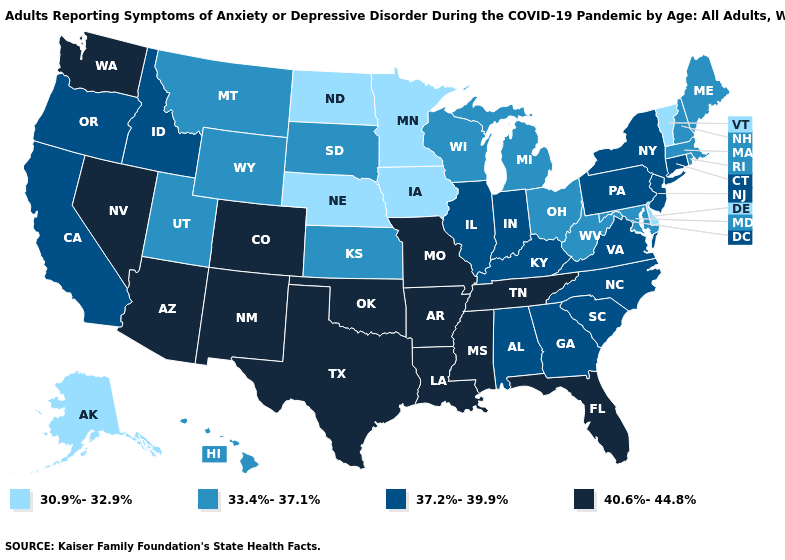Among the states that border Kansas , does Colorado have the lowest value?
Be succinct. No. Does Delaware have a higher value than Nevada?
Short answer required. No. Does Arkansas have the same value as New Mexico?
Keep it brief. Yes. Is the legend a continuous bar?
Concise answer only. No. Name the states that have a value in the range 37.2%-39.9%?
Be succinct. Alabama, California, Connecticut, Georgia, Idaho, Illinois, Indiana, Kentucky, New Jersey, New York, North Carolina, Oregon, Pennsylvania, South Carolina, Virginia. How many symbols are there in the legend?
Write a very short answer. 4. What is the highest value in the Northeast ?
Short answer required. 37.2%-39.9%. Among the states that border New Mexico , which have the highest value?
Quick response, please. Arizona, Colorado, Oklahoma, Texas. Does Alabama have the lowest value in the South?
Give a very brief answer. No. What is the highest value in the West ?
Give a very brief answer. 40.6%-44.8%. What is the lowest value in the South?
Give a very brief answer. 30.9%-32.9%. Name the states that have a value in the range 40.6%-44.8%?
Answer briefly. Arizona, Arkansas, Colorado, Florida, Louisiana, Mississippi, Missouri, Nevada, New Mexico, Oklahoma, Tennessee, Texas, Washington. Does Arizona have the highest value in the USA?
Short answer required. Yes. What is the value of South Dakota?
Give a very brief answer. 33.4%-37.1%. 